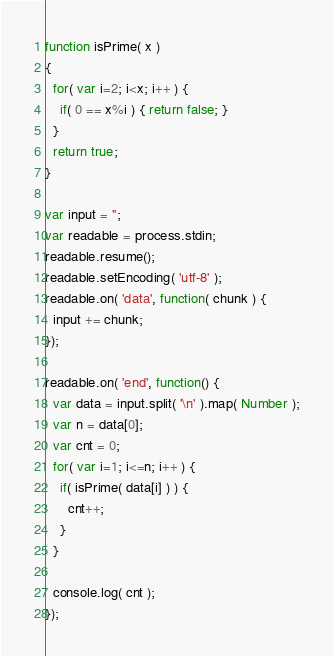Convert code to text. <code><loc_0><loc_0><loc_500><loc_500><_JavaScript_>function isPrime( x )
{
  for( var i=2; i<x; i++ ) {
    if( 0 == x%i ) { return false; }
  }
  return true;
}

var input = '';
var readable = process.stdin;
readable.resume();
readable.setEncoding( 'utf-8' );
readable.on( 'data', function( chunk ) {
  input += chunk;
});

readable.on( 'end', function() {
  var data = input.split( '\n' ).map( Number );
  var n = data[0];
  var cnt = 0;
  for( var i=1; i<=n; i++ ) {
    if( isPrime( data[i] ) ) {
      cnt++;
    }
  }
  
  console.log( cnt );
});</code> 